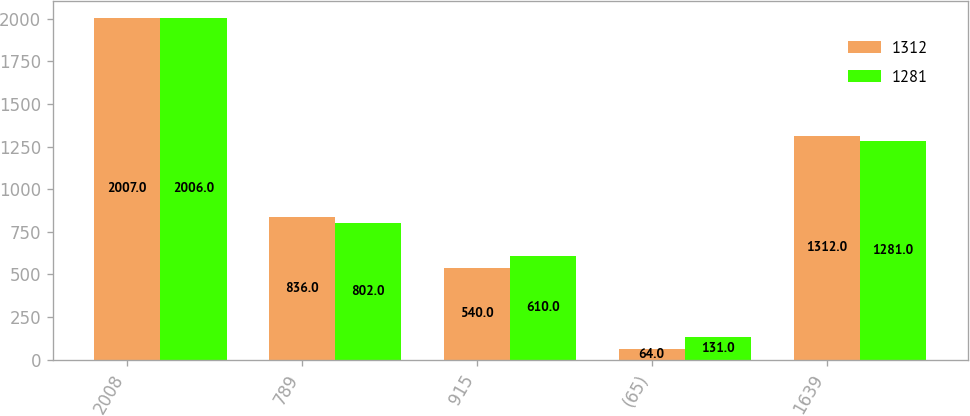Convert chart to OTSL. <chart><loc_0><loc_0><loc_500><loc_500><stacked_bar_chart><ecel><fcel>2008<fcel>789<fcel>915<fcel>(65)<fcel>1639<nl><fcel>1312<fcel>2007<fcel>836<fcel>540<fcel>64<fcel>1312<nl><fcel>1281<fcel>2006<fcel>802<fcel>610<fcel>131<fcel>1281<nl></chart> 